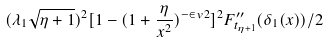<formula> <loc_0><loc_0><loc_500><loc_500>( \lambda _ { 1 } \sqrt { \eta + 1 } ) ^ { 2 } [ 1 - ( 1 + \frac { \eta } { x ^ { 2 } } ) ^ { - \in v { 2 } } ] ^ { 2 } F ^ { \prime \prime } _ { t _ { \eta + 1 } } ( \delta _ { 1 } ( x ) ) / 2</formula> 